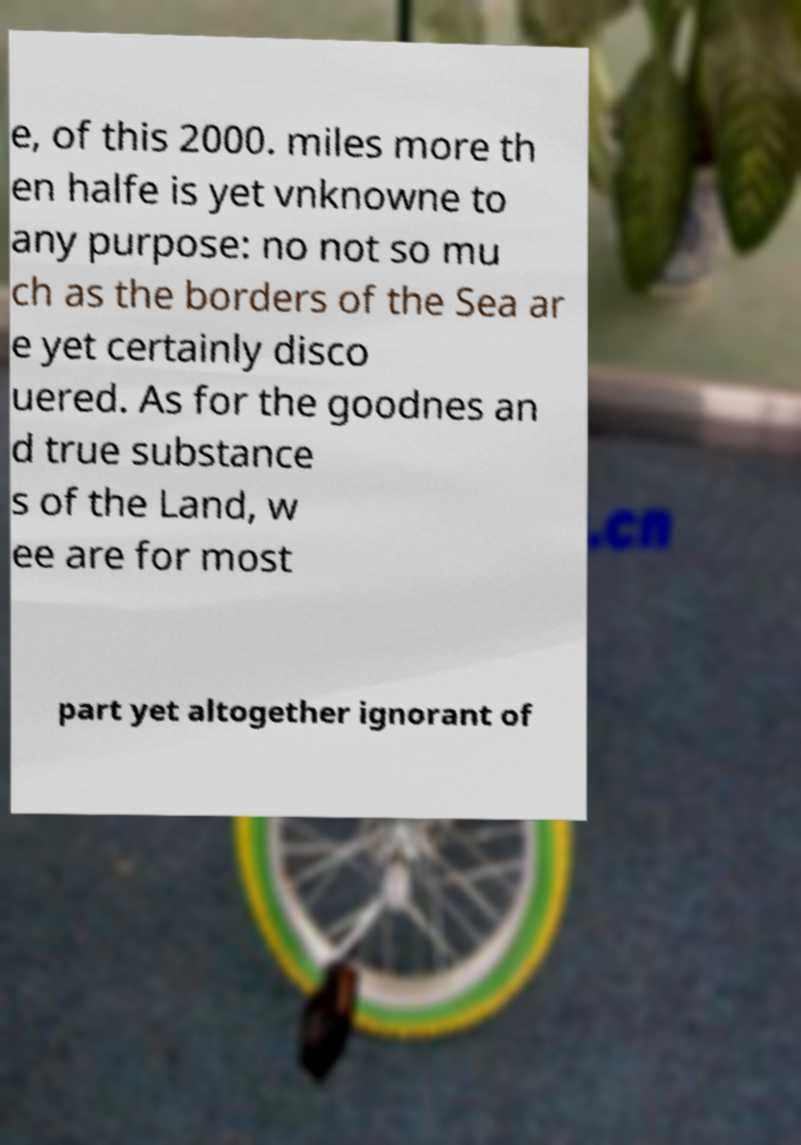There's text embedded in this image that I need extracted. Can you transcribe it verbatim? e, of this 2000. miles more th en halfe is yet vnknowne to any purpose: no not so mu ch as the borders of the Sea ar e yet certainly disco uered. As for the goodnes an d true substance s of the Land, w ee are for most part yet altogether ignorant of 